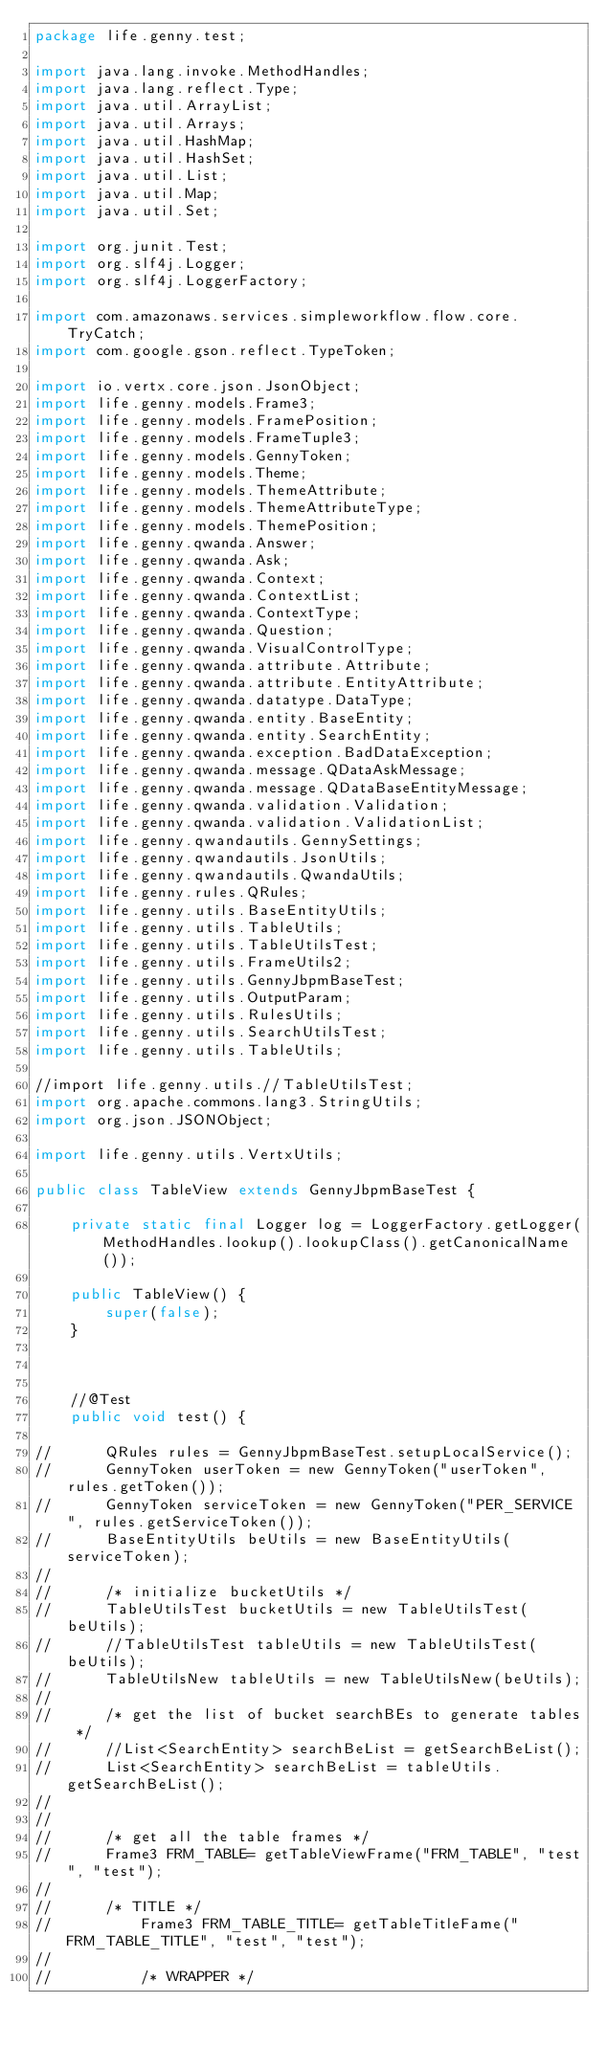Convert code to text. <code><loc_0><loc_0><loc_500><loc_500><_Java_>package life.genny.test;

import java.lang.invoke.MethodHandles;
import java.lang.reflect.Type;
import java.util.ArrayList;
import java.util.Arrays;
import java.util.HashMap;
import java.util.HashSet;
import java.util.List;
import java.util.Map;
import java.util.Set;

import org.junit.Test;
import org.slf4j.Logger;
import org.slf4j.LoggerFactory;

import com.amazonaws.services.simpleworkflow.flow.core.TryCatch;
import com.google.gson.reflect.TypeToken;

import io.vertx.core.json.JsonObject;
import life.genny.models.Frame3;
import life.genny.models.FramePosition;
import life.genny.models.FrameTuple3;
import life.genny.models.GennyToken;
import life.genny.models.Theme;
import life.genny.models.ThemeAttribute;
import life.genny.models.ThemeAttributeType;
import life.genny.models.ThemePosition;
import life.genny.qwanda.Answer;
import life.genny.qwanda.Ask;
import life.genny.qwanda.Context;
import life.genny.qwanda.ContextList;
import life.genny.qwanda.ContextType;
import life.genny.qwanda.Question;
import life.genny.qwanda.VisualControlType;
import life.genny.qwanda.attribute.Attribute;
import life.genny.qwanda.attribute.EntityAttribute;
import life.genny.qwanda.datatype.DataType;
import life.genny.qwanda.entity.BaseEntity;
import life.genny.qwanda.entity.SearchEntity;
import life.genny.qwanda.exception.BadDataException;
import life.genny.qwanda.message.QDataAskMessage;
import life.genny.qwanda.message.QDataBaseEntityMessage;
import life.genny.qwanda.validation.Validation;
import life.genny.qwanda.validation.ValidationList;
import life.genny.qwandautils.GennySettings;
import life.genny.qwandautils.JsonUtils;
import life.genny.qwandautils.QwandaUtils;
import life.genny.rules.QRules;
import life.genny.utils.BaseEntityUtils;
import life.genny.utils.TableUtils;
import life.genny.utils.TableUtilsTest;
import life.genny.utils.FrameUtils2;
import life.genny.utils.GennyJbpmBaseTest;
import life.genny.utils.OutputParam;
import life.genny.utils.RulesUtils;
import life.genny.utils.SearchUtilsTest;
import life.genny.utils.TableUtils;

//import life.genny.utils.//TableUtilsTest;
import org.apache.commons.lang3.StringUtils;
import org.json.JSONObject;

import life.genny.utils.VertxUtils;

public class TableView extends GennyJbpmBaseTest {

	private static final Logger log = LoggerFactory.getLogger(MethodHandles.lookup().lookupClass().getCanonicalName());

	public TableView() {
		super(false);
	}

	

	//@Test
	public void test() {

//		QRules rules = GennyJbpmBaseTest.setupLocalService();
//		GennyToken userToken = new GennyToken("userToken", rules.getToken());
//		GennyToken serviceToken = new GennyToken("PER_SERVICE", rules.getServiceToken());
//		BaseEntityUtils beUtils = new BaseEntityUtils(serviceToken);
//
//		/* initialize bucketUtils */
//		TableUtilsTest bucketUtils = new TableUtilsTest(beUtils);
//		//TableUtilsTest tableUtils = new TableUtilsTest(beUtils);
//		TableUtilsNew tableUtils = new TableUtilsNew(beUtils);
//
//		/* get the list of bucket searchBEs to generate tables */
//		//List<SearchEntity> searchBeList = getSearchBeList();
//		List<SearchEntity> searchBeList = tableUtils.getSearchBeList();
//
//
//		/* get all the table frames */
//		Frame3 FRM_TABLE= getTableViewFrame("FRM_TABLE", "test", "test");
//
//		/* TITLE */
//			Frame3 FRM_TABLE_TITLE= getTableTitleFame("FRM_TABLE_TITLE", "test", "test");
//			
//			/* WRAPPER */</code> 